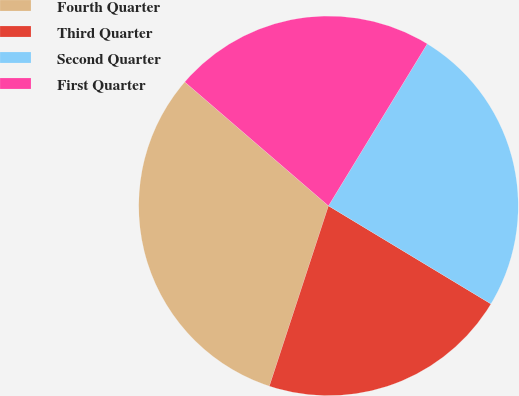Convert chart. <chart><loc_0><loc_0><loc_500><loc_500><pie_chart><fcel>Fourth Quarter<fcel>Third Quarter<fcel>Second Quarter<fcel>First Quarter<nl><fcel>31.28%<fcel>21.4%<fcel>24.93%<fcel>22.39%<nl></chart> 